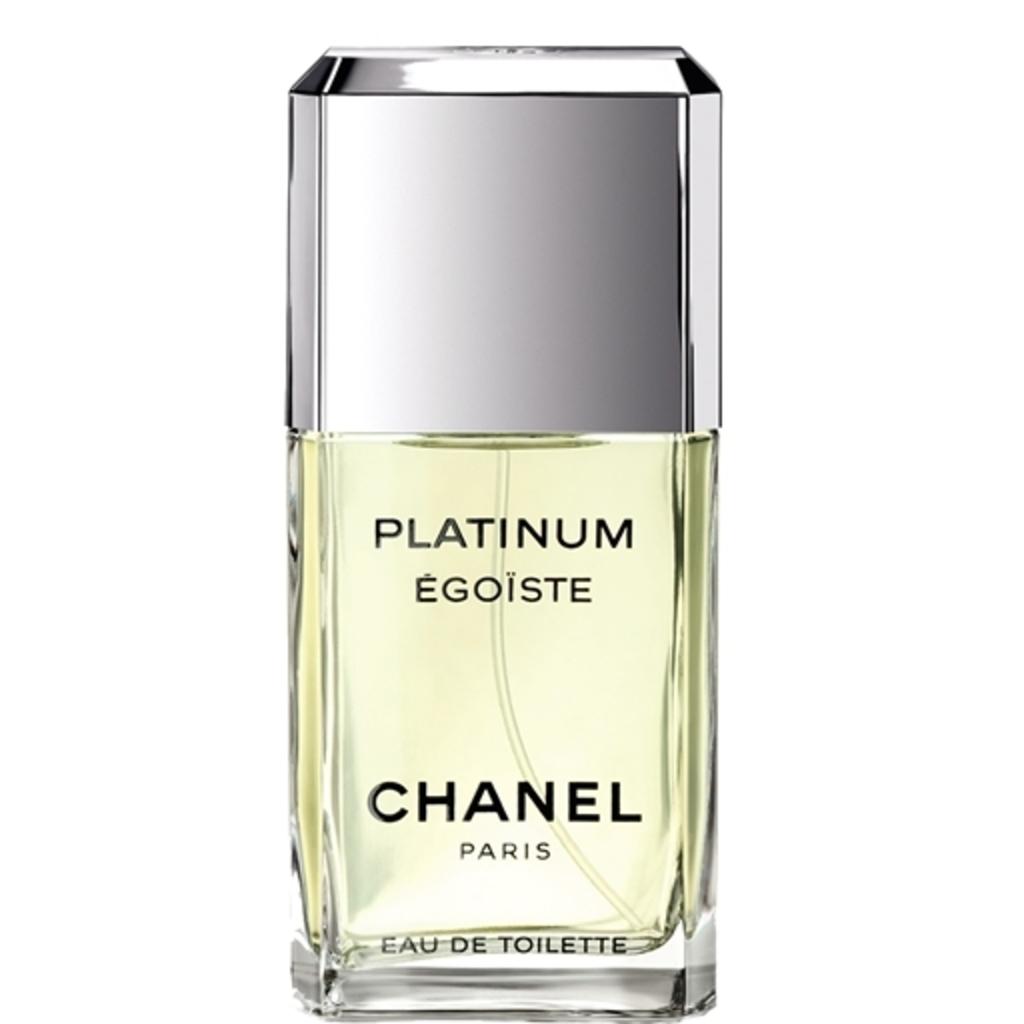What brand is the perfume?
Give a very brief answer. Chanel. 